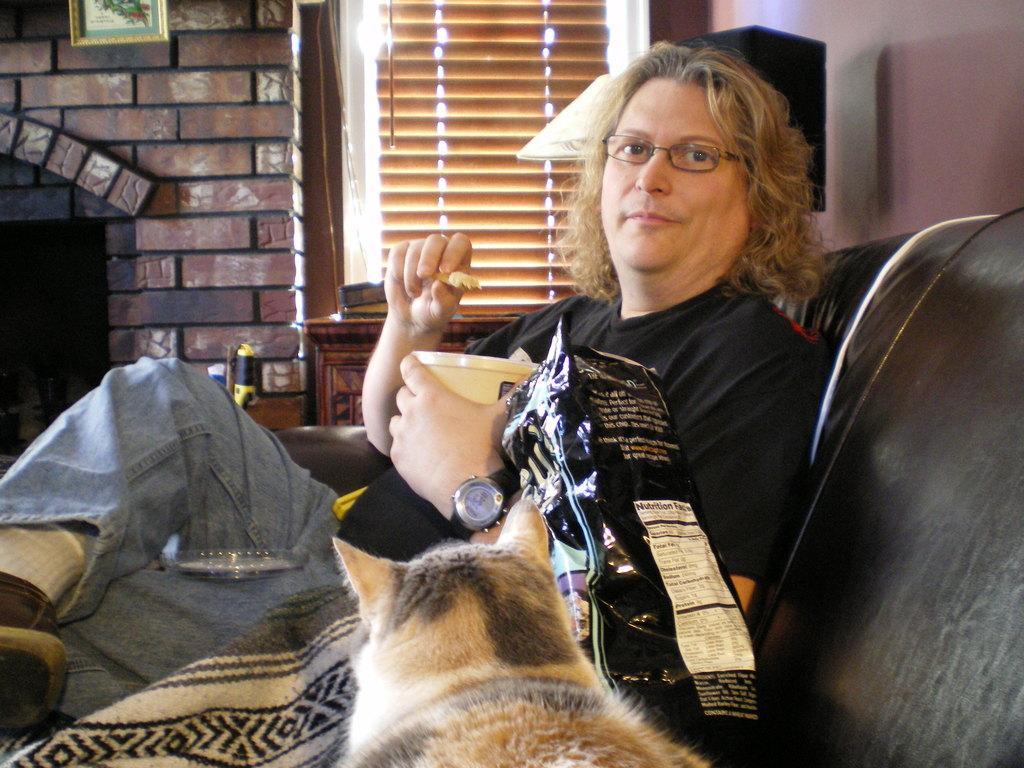Please provide a concise description of this image. In this image there is a man sitting in the couch and eating the food in the bowl , there is a dog beside him and a t back ground there is a fire place, frame to the wall, table, window, speaker. 